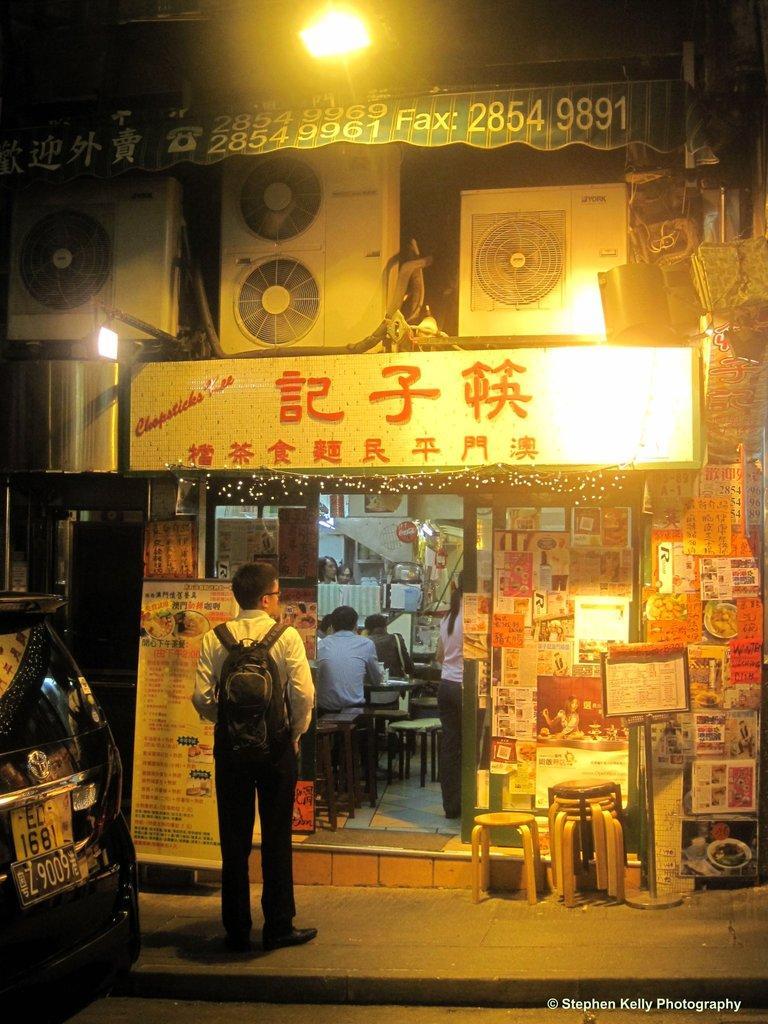Can you describe this image briefly? In this image there is a vehicle on a road and a man standing on a footpath, in the background there is a shop near the shop there are chairs, inside the shop there are people sitting on chairs, at the top there is a lights, AC vents and a board, on that board there is some text, on the bottom right there is some text. 